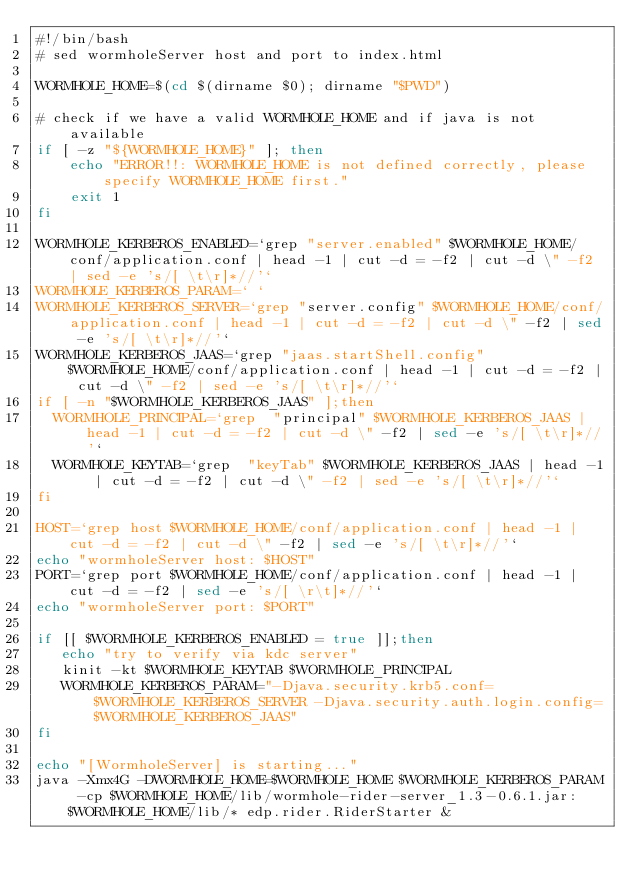Convert code to text. <code><loc_0><loc_0><loc_500><loc_500><_Bash_>#!/bin/bash
# sed wormholeServer host and port to index.html

WORMHOLE_HOME=$(cd $(dirname $0); dirname "$PWD")

# check if we have a valid WORMHOLE_HOME and if java is not available
if [ -z "${WORMHOLE_HOME}" ]; then
    echo "ERROR!!: WORMHOLE_HOME is not defined correctly, please specify WORMHOLE_HOME first."
    exit 1
fi

WORMHOLE_KERBEROS_ENABLED=`grep "server.enabled" $WORMHOLE_HOME/conf/application.conf | head -1 | cut -d = -f2 | cut -d \" -f2 | sed -e 's/[ \t\r]*//'`
WORMHOLE_KERBEROS_PARAM=` `
WORMHOLE_KERBEROS_SERVER=`grep "server.config" $WORMHOLE_HOME/conf/application.conf | head -1 | cut -d = -f2 | cut -d \" -f2 | sed -e 's/[ \t\r]*//'`
WORMHOLE_KERBEROS_JAAS=`grep "jaas.startShell.config" $WORMHOLE_HOME/conf/application.conf | head -1 | cut -d = -f2 | cut -d \" -f2 | sed -e 's/[ \t\r]*//'`
if [ -n "$WORMHOLE_KERBEROS_JAAS" ];then
  WORMHOLE_PRINCIPAL=`grep  "principal" $WORMHOLE_KERBEROS_JAAS | head -1 | cut -d = -f2 | cut -d \" -f2 | sed -e 's/[ \t\r]*//'`
  WORMHOLE_KEYTAB=`grep  "keyTab" $WORMHOLE_KERBEROS_JAAS | head -1 | cut -d = -f2 | cut -d \" -f2 | sed -e 's/[ \t\r]*//'`
fi

HOST=`grep host $WORMHOLE_HOME/conf/application.conf | head -1 | cut -d = -f2 | cut -d \" -f2 | sed -e 's/[ \t\r]*//'`
echo "wormholeServer host: $HOST"
PORT=`grep port $WORMHOLE_HOME/conf/application.conf | head -1 | cut -d = -f2 | sed -e 's/[ \r\t]*//'`
echo "wormholeServer port: $PORT"

if [[ $WORMHOLE_KERBEROS_ENABLED = true ]];then
   echo "try to verify via kdc server"
   kinit -kt $WORMHOLE_KEYTAB $WORMHOLE_PRINCIPAL
   WORMHOLE_KERBEROS_PARAM="-Djava.security.krb5.conf=$WORMHOLE_KERBEROS_SERVER -Djava.security.auth.login.config=$WORMHOLE_KERBEROS_JAAS"
fi

echo "[WormholeServer] is starting..."
java -Xmx4G -DWORMHOLE_HOME=$WORMHOLE_HOME $WORMHOLE_KERBEROS_PARAM -cp $WORMHOLE_HOME/lib/wormhole-rider-server_1.3-0.6.1.jar:$WORMHOLE_HOME/lib/* edp.rider.RiderStarter &
</code> 